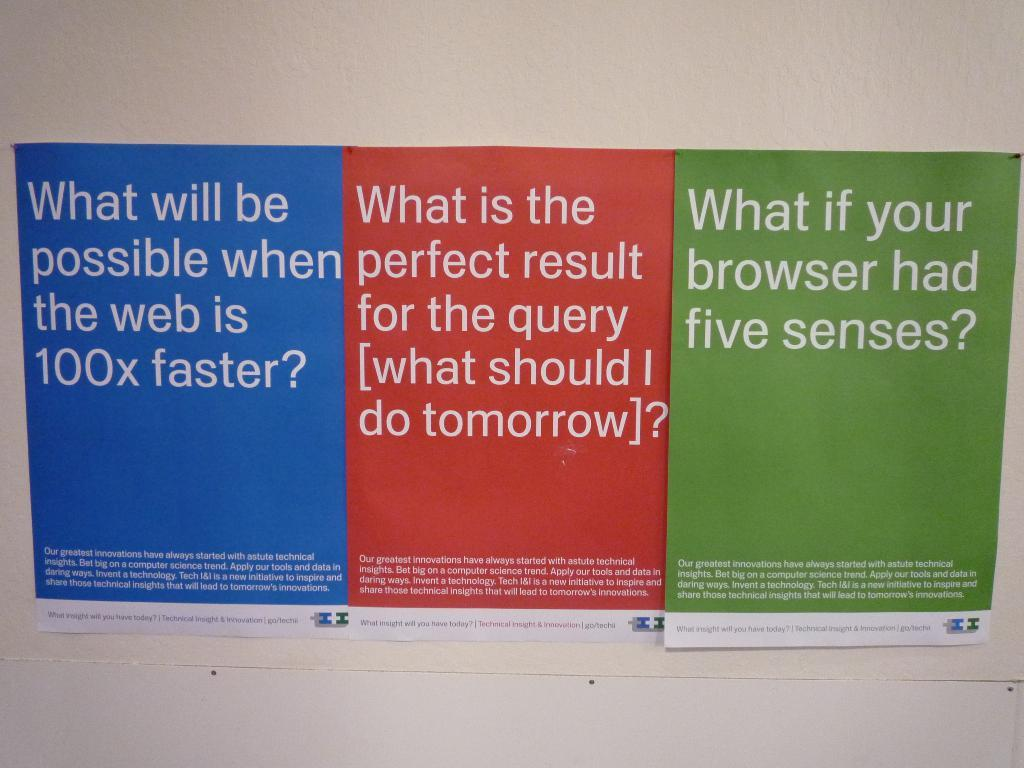<image>
Present a compact description of the photo's key features. Three signs with one that reads What if your browser had five senses 